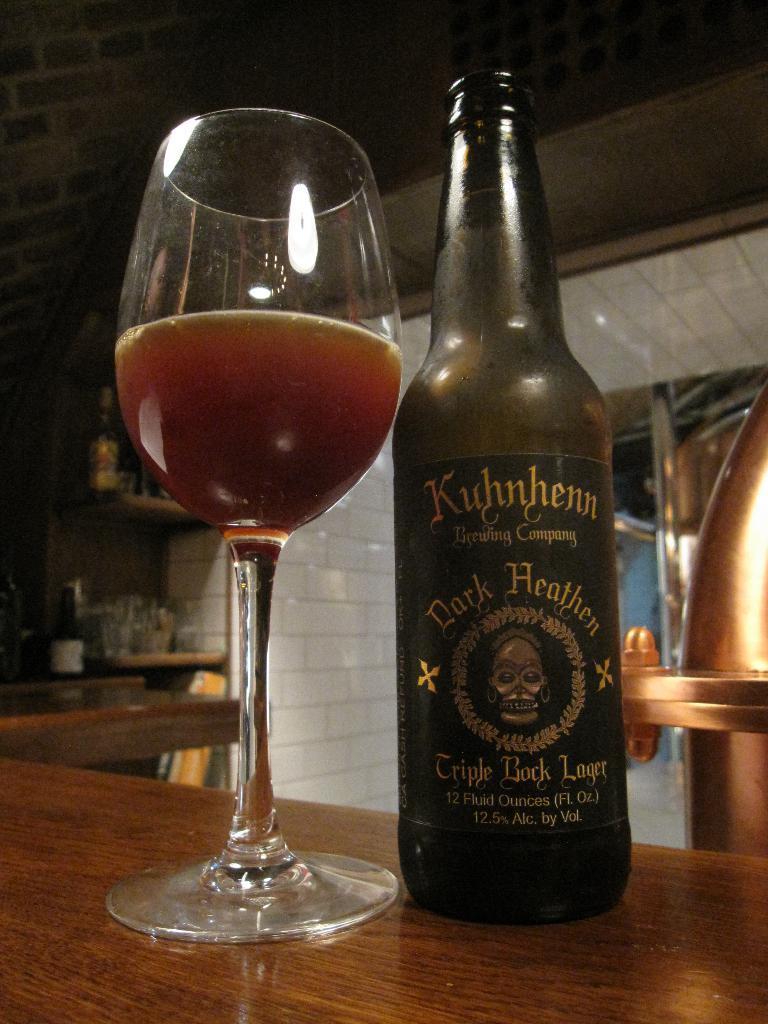Please provide a concise description of this image. In the center of the image there is a bottle and a wine glass placed on the table. In the background there is a wall and a shelf. 